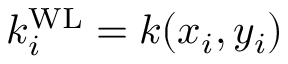Convert formula to latex. <formula><loc_0><loc_0><loc_500><loc_500>k _ { i } ^ { W L } = k ( x _ { i } , y _ { i } )</formula> 